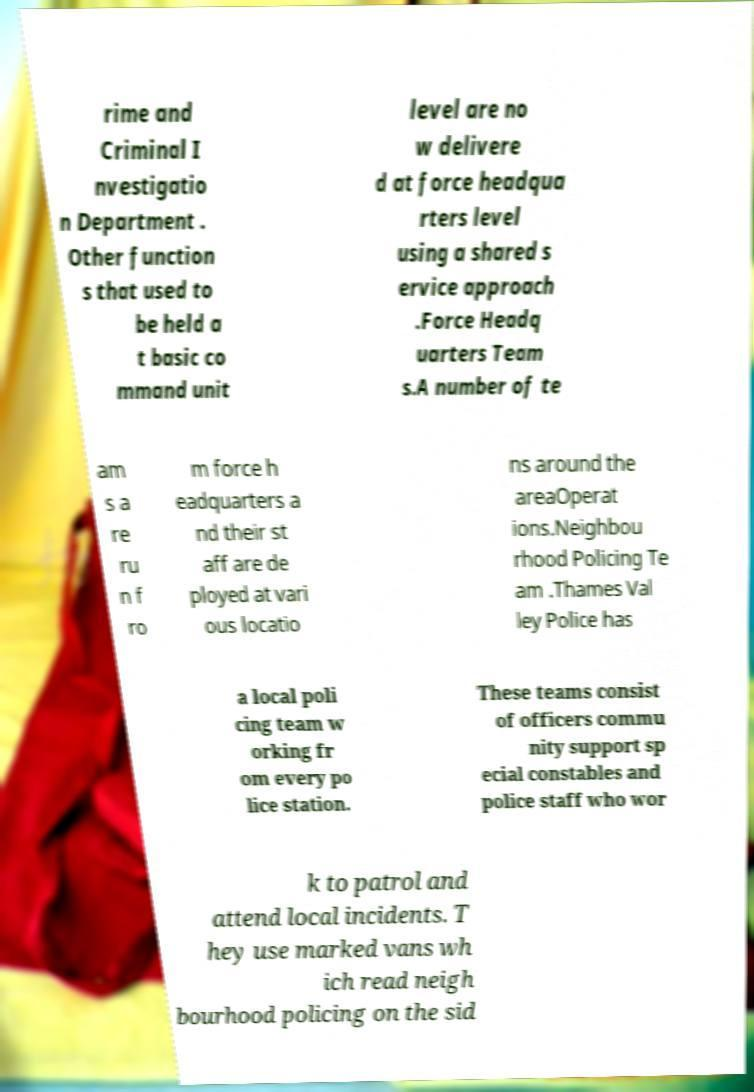I need the written content from this picture converted into text. Can you do that? rime and Criminal I nvestigatio n Department . Other function s that used to be held a t basic co mmand unit level are no w delivere d at force headqua rters level using a shared s ervice approach .Force Headq uarters Team s.A number of te am s a re ru n f ro m force h eadquarters a nd their st aff are de ployed at vari ous locatio ns around the areaOperat ions.Neighbou rhood Policing Te am .Thames Val ley Police has a local poli cing team w orking fr om every po lice station. These teams consist of officers commu nity support sp ecial constables and police staff who wor k to patrol and attend local incidents. T hey use marked vans wh ich read neigh bourhood policing on the sid 